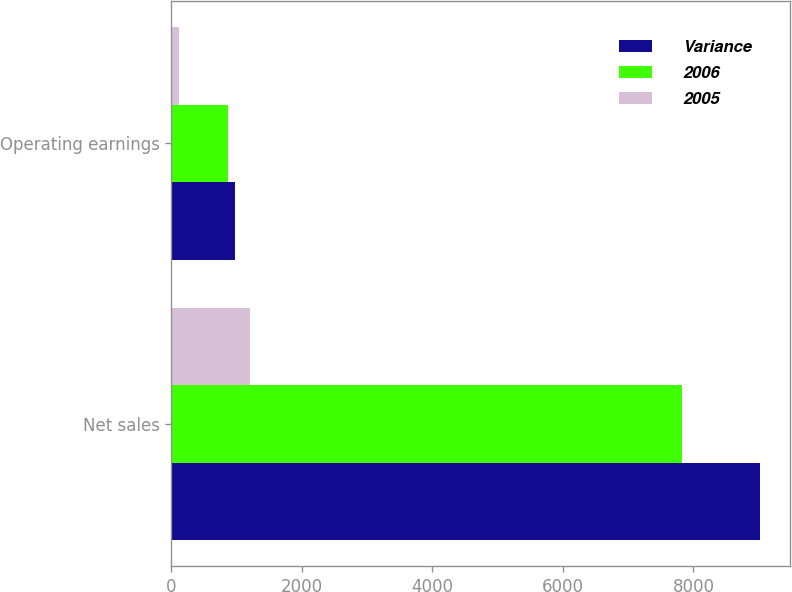Convert chart to OTSL. <chart><loc_0><loc_0><loc_500><loc_500><stacked_bar_chart><ecel><fcel>Net sales<fcel>Operating earnings<nl><fcel>Variance<fcel>9024<fcel>976<nl><fcel>2006<fcel>7826<fcel>865<nl><fcel>2005<fcel>1198<fcel>111<nl></chart> 